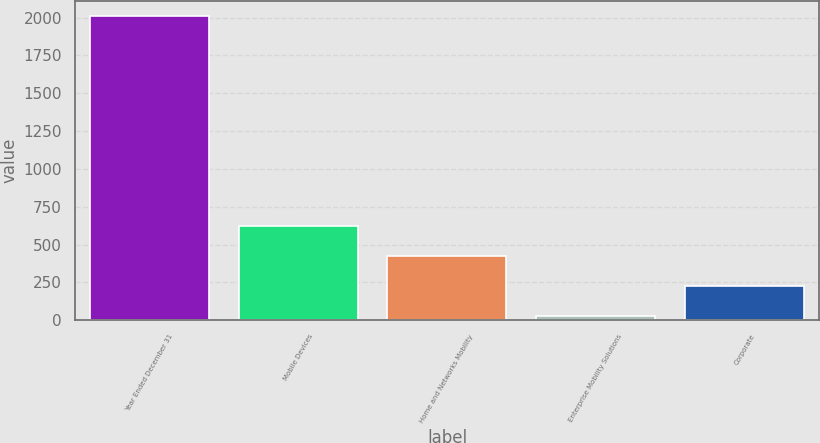Convert chart to OTSL. <chart><loc_0><loc_0><loc_500><loc_500><bar_chart><fcel>Year Ended December 31<fcel>Mobile Devices<fcel>Home and Networks Mobility<fcel>Enterprise Mobility Solutions<fcel>Corporate<nl><fcel>2008<fcel>621.3<fcel>423.2<fcel>27<fcel>225.1<nl></chart> 